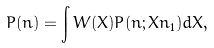<formula> <loc_0><loc_0><loc_500><loc_500>P ( n ) = \int W ( X ) P ( n ; X \bar { n } _ { 1 } ) d X ,</formula> 